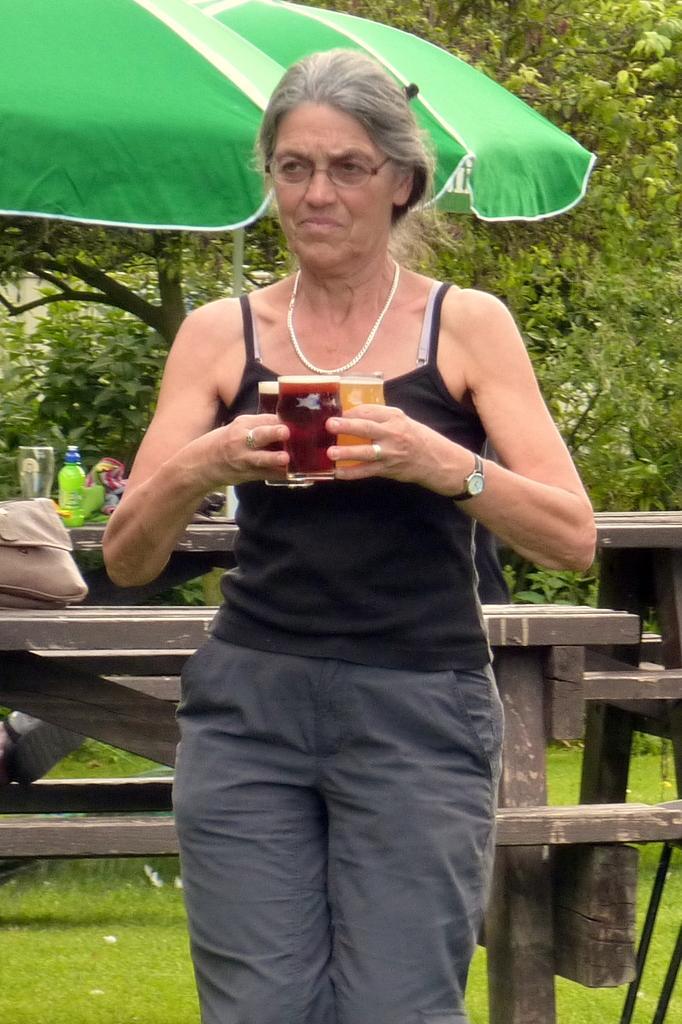How would you summarize this image in a sentence or two? This picture is clicked outside. In the foreground we can see a woman holding the glasses of drinks and seems to be standing. In the background we can see the bottle, glass and some other objects are placed on the top of the tables and we can see the benches, umbrella, metal rod, trees and the green grass. 